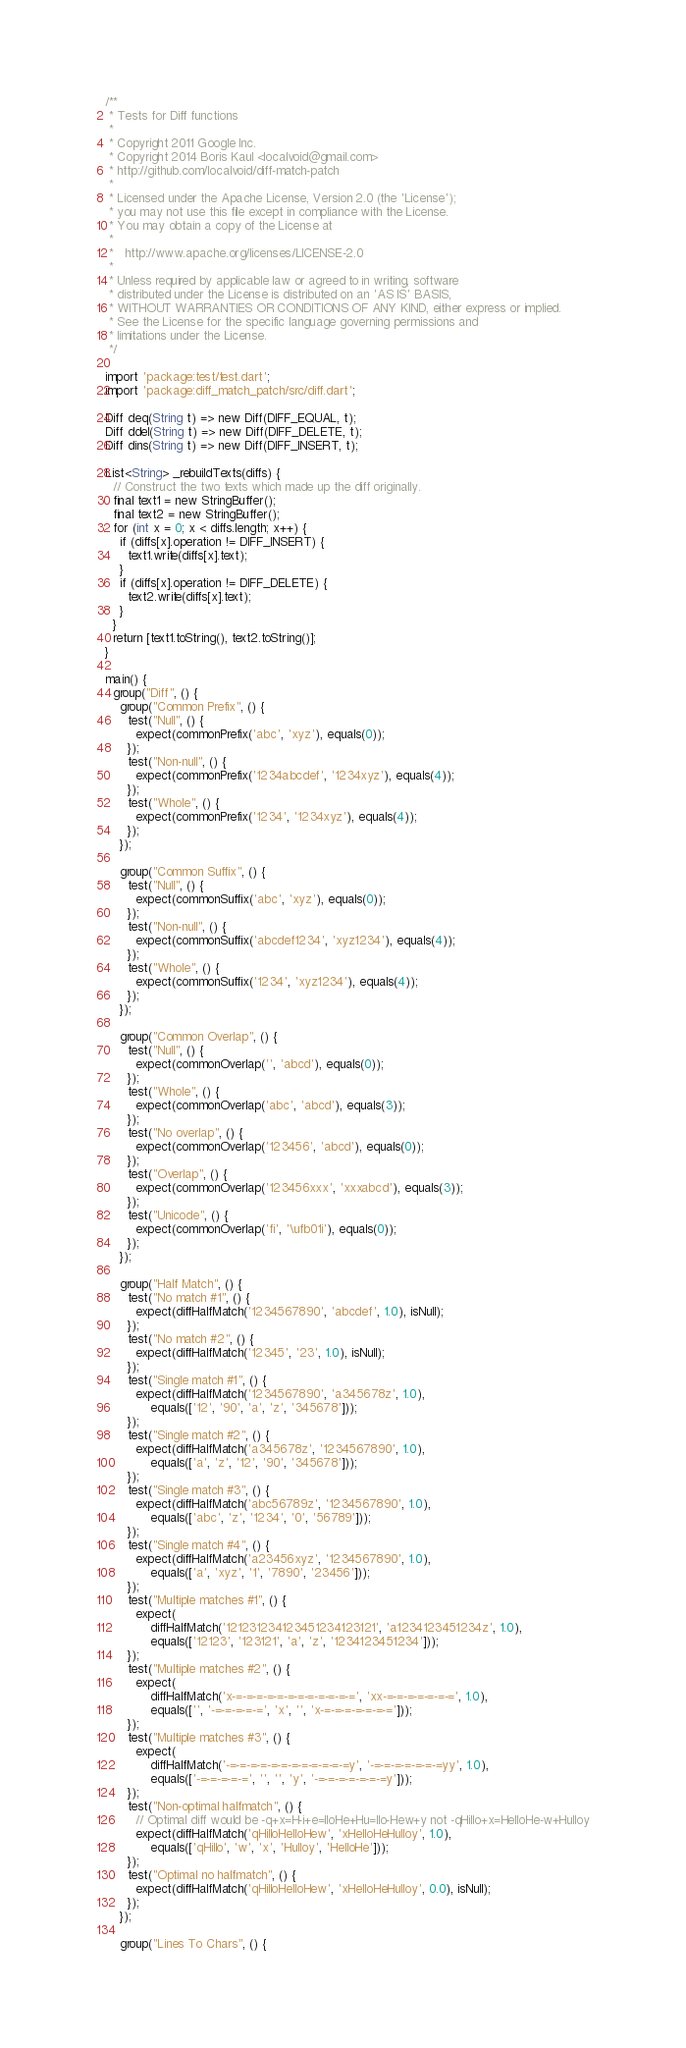<code> <loc_0><loc_0><loc_500><loc_500><_Dart_>/**
 * Tests for Diff functions
 *
 * Copyright 2011 Google Inc.
 * Copyright 2014 Boris Kaul <localvoid@gmail.com>
 * http://github.com/localvoid/diff-match-patch
 *
 * Licensed under the Apache License, Version 2.0 (the 'License');
 * you may not use this file except in compliance with the License.
 * You may obtain a copy of the License at
 *
 *   http://www.apache.org/licenses/LICENSE-2.0
 *
 * Unless required by applicable law or agreed to in writing, software
 * distributed under the License is distributed on an 'AS IS' BASIS,
 * WITHOUT WARRANTIES OR CONDITIONS OF ANY KIND, either express or implied.
 * See the License for the specific language governing permissions and
 * limitations under the License.
 */

import 'package:test/test.dart';
import 'package:diff_match_patch/src/diff.dart';

Diff deq(String t) => new Diff(DIFF_EQUAL, t);
Diff ddel(String t) => new Diff(DIFF_DELETE, t);
Diff dins(String t) => new Diff(DIFF_INSERT, t);

List<String> _rebuildTexts(diffs) {
  // Construct the two texts which made up the diff originally.
  final text1 = new StringBuffer();
  final text2 = new StringBuffer();
  for (int x = 0; x < diffs.length; x++) {
    if (diffs[x].operation != DIFF_INSERT) {
      text1.write(diffs[x].text);
    }
    if (diffs[x].operation != DIFF_DELETE) {
      text2.write(diffs[x].text);
    }
  }
  return [text1.toString(), text2.toString()];
}

main() {
  group("Diff", () {
    group("Common Prefix", () {
      test("Null", () {
        expect(commonPrefix('abc', 'xyz'), equals(0));
      });
      test("Non-null", () {
        expect(commonPrefix('1234abcdef', '1234xyz'), equals(4));
      });
      test("Whole", () {
        expect(commonPrefix('1234', '1234xyz'), equals(4));
      });
    });

    group("Common Suffix", () {
      test("Null", () {
        expect(commonSuffix('abc', 'xyz'), equals(0));
      });
      test("Non-null", () {
        expect(commonSuffix('abcdef1234', 'xyz1234'), equals(4));
      });
      test("Whole", () {
        expect(commonSuffix('1234', 'xyz1234'), equals(4));
      });
    });

    group("Common Overlap", () {
      test("Null", () {
        expect(commonOverlap('', 'abcd'), equals(0));
      });
      test("Whole", () {
        expect(commonOverlap('abc', 'abcd'), equals(3));
      });
      test("No overlap", () {
        expect(commonOverlap('123456', 'abcd'), equals(0));
      });
      test("Overlap", () {
        expect(commonOverlap('123456xxx', 'xxxabcd'), equals(3));
      });
      test("Unicode", () {
        expect(commonOverlap('fi', '\ufb01i'), equals(0));
      });
    });

    group("Half Match", () {
      test("No match #1", () {
        expect(diffHalfMatch('1234567890', 'abcdef', 1.0), isNull);
      });
      test("No match #2", () {
        expect(diffHalfMatch('12345', '23', 1.0), isNull);
      });
      test("Single match #1", () {
        expect(diffHalfMatch('1234567890', 'a345678z', 1.0),
            equals(['12', '90', 'a', 'z', '345678']));
      });
      test("Single match #2", () {
        expect(diffHalfMatch('a345678z', '1234567890', 1.0),
            equals(['a', 'z', '12', '90', '345678']));
      });
      test("Single match #3", () {
        expect(diffHalfMatch('abc56789z', '1234567890', 1.0),
            equals(['abc', 'z', '1234', '0', '56789']));
      });
      test("Single match #4", () {
        expect(diffHalfMatch('a23456xyz', '1234567890', 1.0),
            equals(['a', 'xyz', '1', '7890', '23456']));
      });
      test("Multiple matches #1", () {
        expect(
            diffHalfMatch('121231234123451234123121', 'a1234123451234z', 1.0),
            equals(['12123', '123121', 'a', 'z', '1234123451234']));
      });
      test("Multiple matches #2", () {
        expect(
            diffHalfMatch('x-=-=-=-=-=-=-=-=-=-=-=-=', 'xx-=-=-=-=-=-=-=', 1.0),
            equals(['', '-=-=-=-=-=', 'x', '', 'x-=-=-=-=-=-=-=']));
      });
      test("Multiple matches #3", () {
        expect(
            diffHalfMatch('-=-=-=-=-=-=-=-=-=-=-=-=y', '-=-=-=-=-=-=-=yy', 1.0),
            equals(['-=-=-=-=-=', '', '', 'y', '-=-=-=-=-=-=-=y']));
      });
      test("Non-optimal halfmatch", () {
        // Optimal diff would be -q+x=H-i+e=lloHe+Hu=llo-Hew+y not -qHillo+x=HelloHe-w+Hulloy
        expect(diffHalfMatch('qHilloHelloHew', 'xHelloHeHulloy', 1.0),
            equals(['qHillo', 'w', 'x', 'Hulloy', 'HelloHe']));
      });
      test("Optimal no halfmatch", () {
        expect(diffHalfMatch('qHilloHelloHew', 'xHelloHeHulloy', 0.0), isNull);
      });
    });

    group("Lines To Chars", () {</code> 